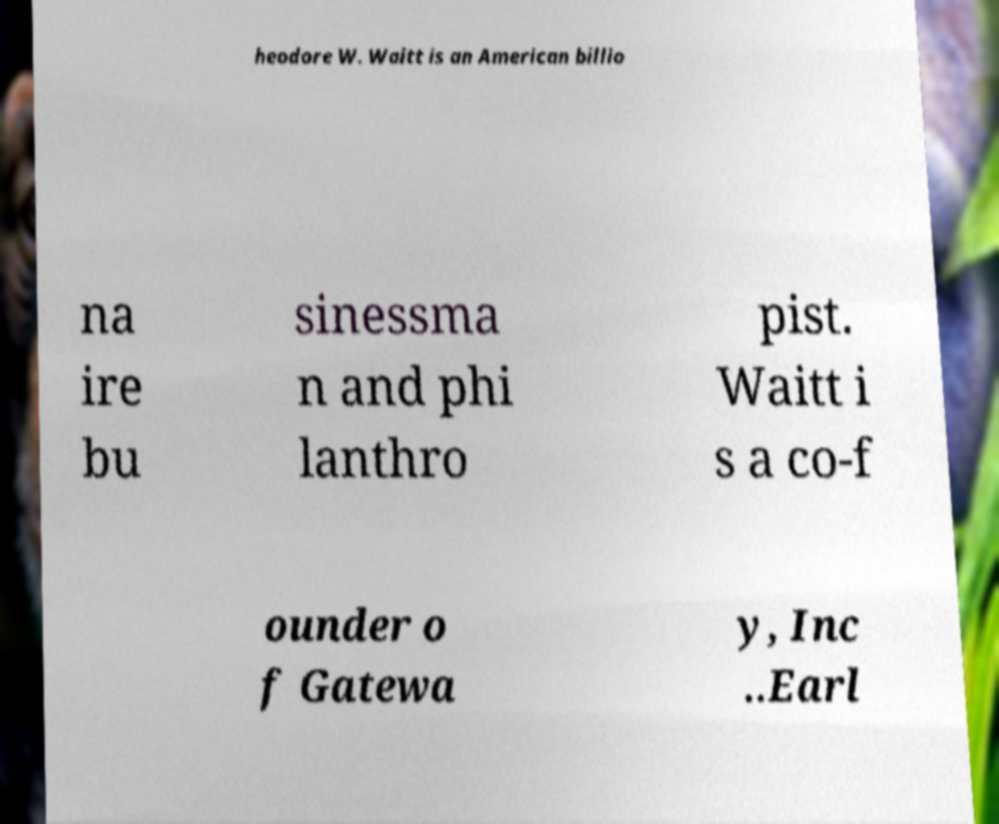What messages or text are displayed in this image? I need them in a readable, typed format. heodore W. Waitt is an American billio na ire bu sinessma n and phi lanthro pist. Waitt i s a co-f ounder o f Gatewa y, Inc ..Earl 